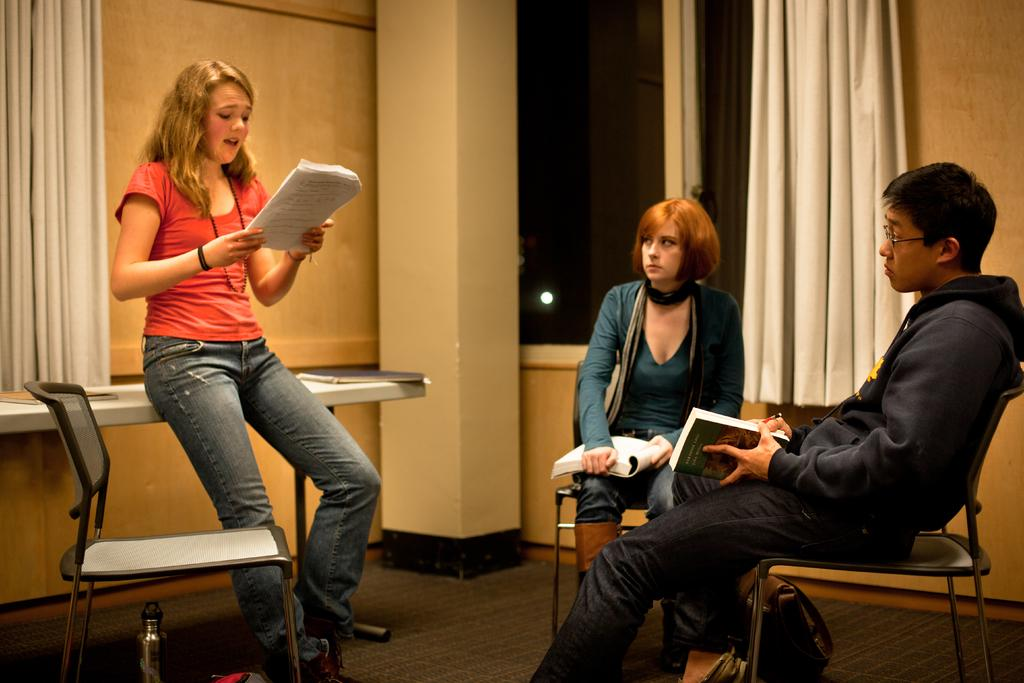Who is the main subject in the image? There is a woman in the image. What is the woman doing in the image? The woman is standing in the image. What is the woman holding in her hand? The woman is holding papers in her hand. What are the other people in the image doing? There are people sitting on chairs in the image, and they are holding books in their hands. How much money is the woman giving to her friend on the sofa in the image? There is no friend or sofa present in the image, and no money is being exchanged. 